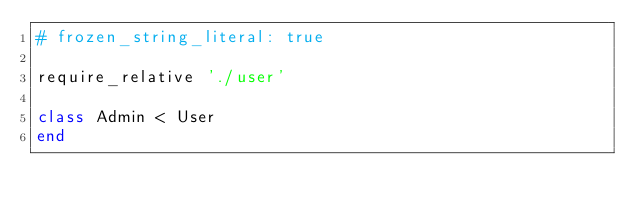Convert code to text. <code><loc_0><loc_0><loc_500><loc_500><_Ruby_># frozen_string_literal: true

require_relative './user'

class Admin < User
end
</code> 